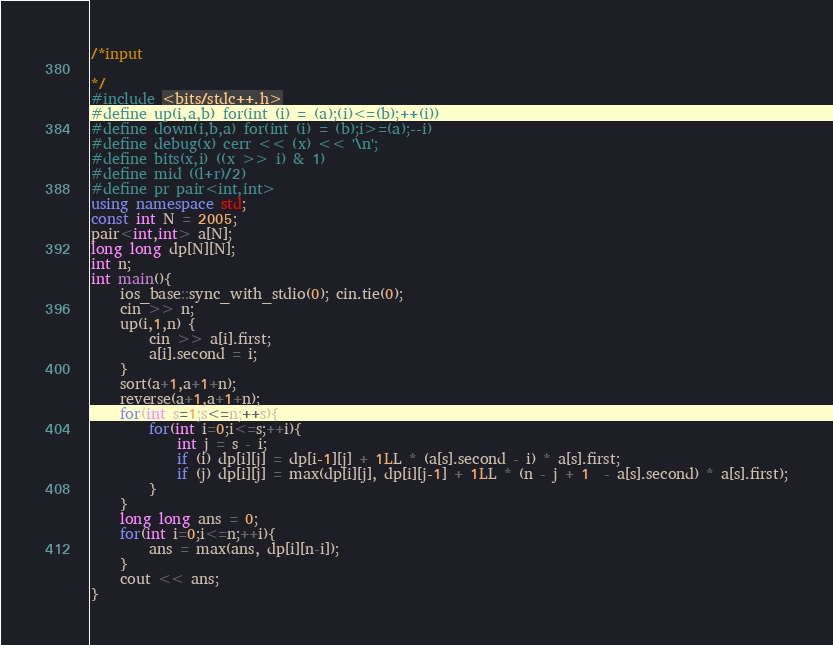<code> <loc_0><loc_0><loc_500><loc_500><_C++_>/*input

*/
#include <bits/stdc++.h>
#define up(i,a,b) for(int (i) = (a);(i)<=(b);++(i))
#define down(i,b,a) for(int (i) = (b);i>=(a);--i)
#define debug(x) cerr << (x) << '\n';
#define bits(x,i) ((x >> i) & 1)
#define mid ((l+r)/2)
#define pr pair<int,int>
using namespace std;
const int N = 2005;
pair<int,int> a[N];
long long dp[N][N];
int n;
int main(){
	ios_base::sync_with_stdio(0); cin.tie(0);
	cin >> n;
	up(i,1,n) {
		cin >> a[i].first;
		a[i].second = i;
	}
	sort(a+1,a+1+n);
	reverse(a+1,a+1+n);
	for(int s=1;s<=n;++s){
		for(int i=0;i<=s;++i){
			int j = s - i;
			if (i) dp[i][j] = dp[i-1][j] + 1LL * (a[s].second - i) * a[s].first;
			if (j) dp[i][j] = max(dp[i][j], dp[i][j-1] + 1LL * (n - j + 1  - a[s].second) * a[s].first);
		}
	}
	long long ans = 0;
	for(int i=0;i<=n;++i){
		ans = max(ans, dp[i][n-i]);
	}
	cout << ans;
}</code> 